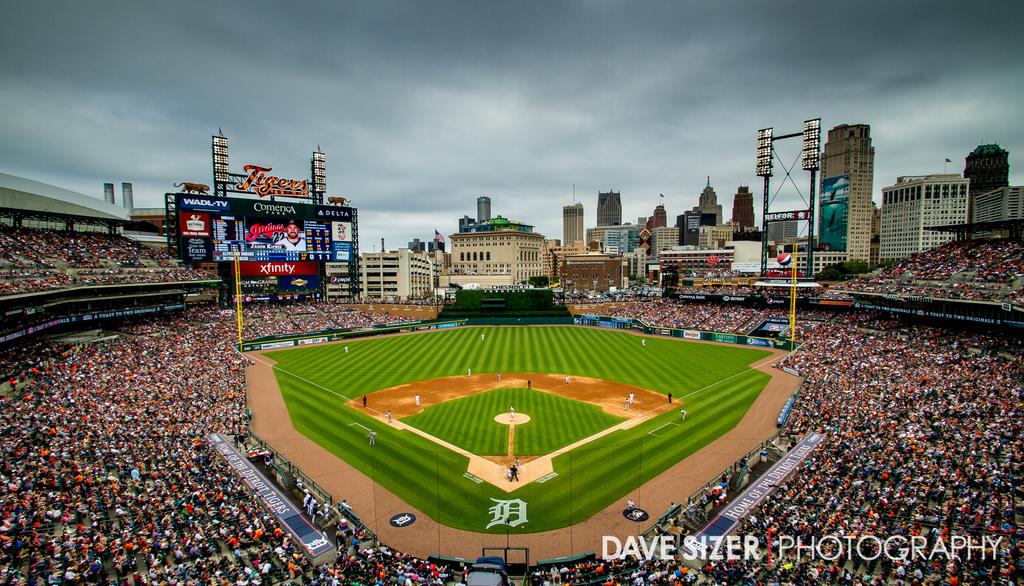What is the stadium's team name?
Offer a terse response. Tigers. 